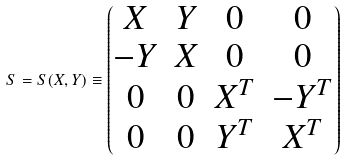<formula> <loc_0><loc_0><loc_500><loc_500>S = S ( X , Y ) \equiv \begin{pmatrix} X & Y & 0 & 0 \\ - Y & X & 0 & 0 \\ 0 & 0 & X ^ { T } & - Y ^ { T } \\ 0 & 0 & Y ^ { T } & X ^ { T } \\ \end{pmatrix}</formula> 